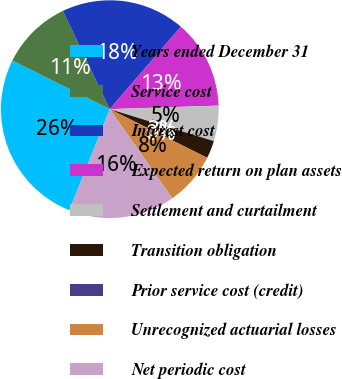Convert chart to OTSL. <chart><loc_0><loc_0><loc_500><loc_500><pie_chart><fcel>Years ended December 31<fcel>Service cost<fcel>Interest cost<fcel>Expected return on plan assets<fcel>Settlement and curtailment<fcel>Transition obligation<fcel>Prior service cost (credit)<fcel>Unrecognized actuarial losses<fcel>Net periodic cost<nl><fcel>26.31%<fcel>10.53%<fcel>18.42%<fcel>13.16%<fcel>5.26%<fcel>2.63%<fcel>0.0%<fcel>7.9%<fcel>15.79%<nl></chart> 